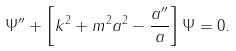Convert formula to latex. <formula><loc_0><loc_0><loc_500><loc_500>\Psi ^ { \prime \prime } + \left [ k ^ { 2 } + m ^ { 2 } a ^ { 2 } - \frac { a ^ { \prime \prime } } { a } \right ] \Psi = 0 .</formula> 